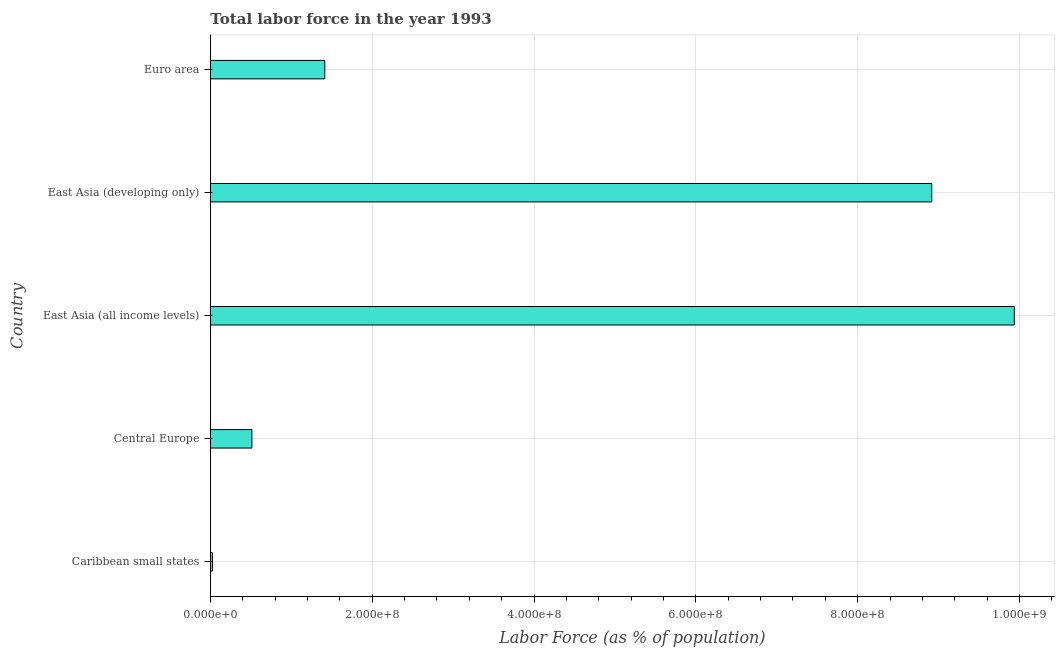What is the title of the graph?
Your answer should be very brief. Total labor force in the year 1993. What is the label or title of the X-axis?
Your answer should be compact. Labor Force (as % of population). What is the total labor force in Central Europe?
Your response must be concise. 5.12e+07. Across all countries, what is the maximum total labor force?
Make the answer very short. 9.94e+08. Across all countries, what is the minimum total labor force?
Provide a succinct answer. 2.55e+06. In which country was the total labor force maximum?
Offer a terse response. East Asia (all income levels). In which country was the total labor force minimum?
Your response must be concise. Caribbean small states. What is the sum of the total labor force?
Offer a very short reply. 2.08e+09. What is the difference between the total labor force in Caribbean small states and East Asia (developing only)?
Offer a terse response. -8.89e+08. What is the average total labor force per country?
Offer a very short reply. 4.16e+08. What is the median total labor force?
Make the answer very short. 1.41e+08. What is the ratio of the total labor force in Central Europe to that in East Asia (all income levels)?
Ensure brevity in your answer.  0.05. Is the total labor force in Caribbean small states less than that in Euro area?
Provide a short and direct response. Yes. Is the difference between the total labor force in Caribbean small states and East Asia (all income levels) greater than the difference between any two countries?
Your answer should be compact. Yes. What is the difference between the highest and the second highest total labor force?
Give a very brief answer. 1.02e+08. What is the difference between the highest and the lowest total labor force?
Your response must be concise. 9.91e+08. How many bars are there?
Ensure brevity in your answer.  5. Are the values on the major ticks of X-axis written in scientific E-notation?
Give a very brief answer. Yes. What is the Labor Force (as % of population) of Caribbean small states?
Give a very brief answer. 2.55e+06. What is the Labor Force (as % of population) in Central Europe?
Offer a very short reply. 5.12e+07. What is the Labor Force (as % of population) of East Asia (all income levels)?
Make the answer very short. 9.94e+08. What is the Labor Force (as % of population) of East Asia (developing only)?
Your answer should be compact. 8.92e+08. What is the Labor Force (as % of population) in Euro area?
Give a very brief answer. 1.41e+08. What is the difference between the Labor Force (as % of population) in Caribbean small states and Central Europe?
Make the answer very short. -4.87e+07. What is the difference between the Labor Force (as % of population) in Caribbean small states and East Asia (all income levels)?
Offer a very short reply. -9.91e+08. What is the difference between the Labor Force (as % of population) in Caribbean small states and East Asia (developing only)?
Offer a terse response. -8.89e+08. What is the difference between the Labor Force (as % of population) in Caribbean small states and Euro area?
Give a very brief answer. -1.39e+08. What is the difference between the Labor Force (as % of population) in Central Europe and East Asia (all income levels)?
Ensure brevity in your answer.  -9.42e+08. What is the difference between the Labor Force (as % of population) in Central Europe and East Asia (developing only)?
Offer a terse response. -8.40e+08. What is the difference between the Labor Force (as % of population) in Central Europe and Euro area?
Your response must be concise. -9.01e+07. What is the difference between the Labor Force (as % of population) in East Asia (all income levels) and East Asia (developing only)?
Your answer should be compact. 1.02e+08. What is the difference between the Labor Force (as % of population) in East Asia (all income levels) and Euro area?
Provide a short and direct response. 8.52e+08. What is the difference between the Labor Force (as % of population) in East Asia (developing only) and Euro area?
Give a very brief answer. 7.50e+08. What is the ratio of the Labor Force (as % of population) in Caribbean small states to that in East Asia (all income levels)?
Provide a succinct answer. 0. What is the ratio of the Labor Force (as % of population) in Caribbean small states to that in East Asia (developing only)?
Your response must be concise. 0. What is the ratio of the Labor Force (as % of population) in Caribbean small states to that in Euro area?
Provide a short and direct response. 0.02. What is the ratio of the Labor Force (as % of population) in Central Europe to that in East Asia (all income levels)?
Offer a terse response. 0.05. What is the ratio of the Labor Force (as % of population) in Central Europe to that in East Asia (developing only)?
Give a very brief answer. 0.06. What is the ratio of the Labor Force (as % of population) in Central Europe to that in Euro area?
Ensure brevity in your answer.  0.36. What is the ratio of the Labor Force (as % of population) in East Asia (all income levels) to that in East Asia (developing only)?
Provide a succinct answer. 1.11. What is the ratio of the Labor Force (as % of population) in East Asia (all income levels) to that in Euro area?
Provide a succinct answer. 7.03. What is the ratio of the Labor Force (as % of population) in East Asia (developing only) to that in Euro area?
Your answer should be very brief. 6.31. 